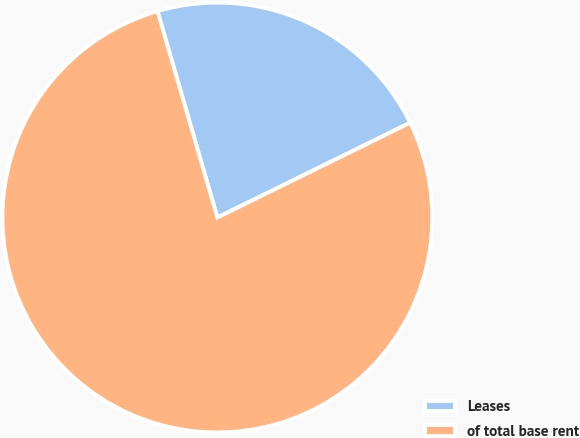Convert chart to OTSL. <chart><loc_0><loc_0><loc_500><loc_500><pie_chart><fcel>Leases<fcel>of total base rent<nl><fcel>22.22%<fcel>77.78%<nl></chart> 